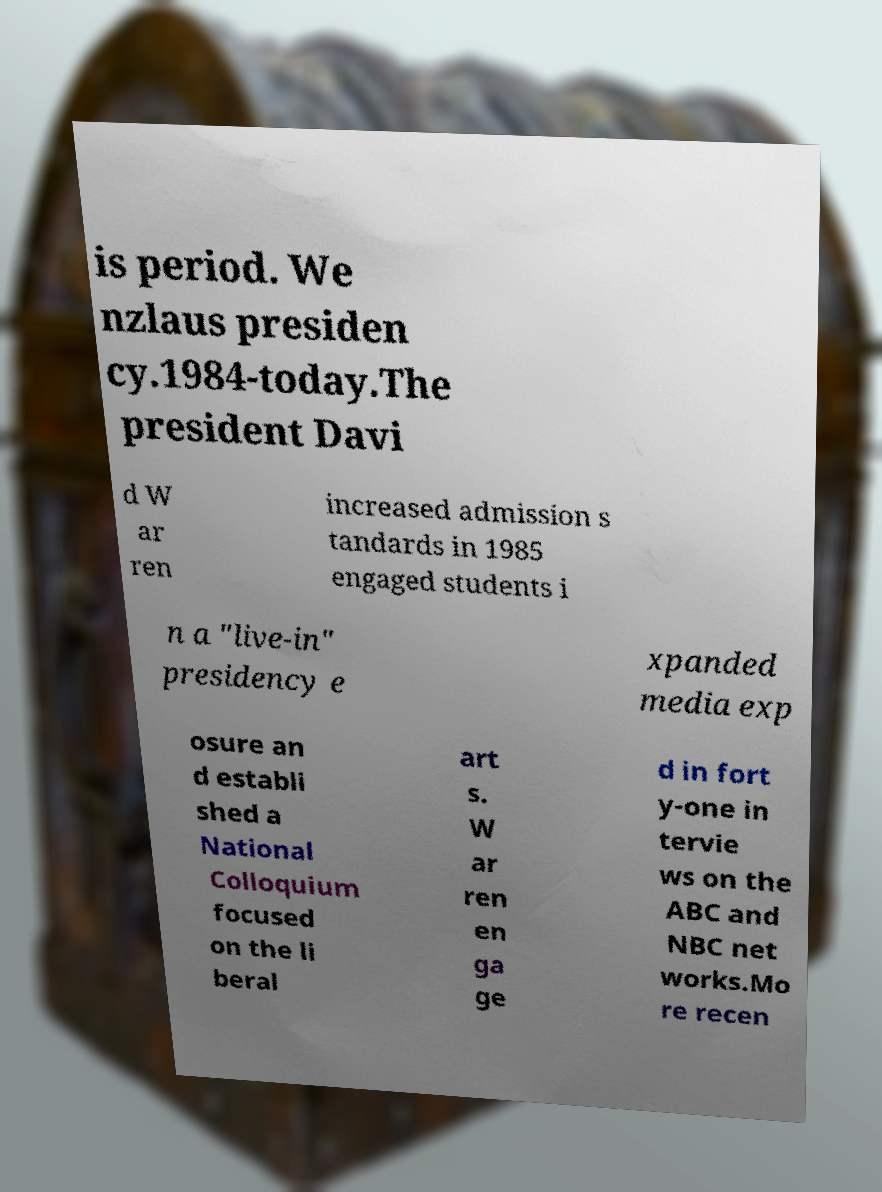What messages or text are displayed in this image? I need them in a readable, typed format. is period. We nzlaus presiden cy.1984-today.The president Davi d W ar ren increased admission s tandards in 1985 engaged students i n a "live-in" presidency e xpanded media exp osure an d establi shed a National Colloquium focused on the li beral art s. W ar ren en ga ge d in fort y-one in tervie ws on the ABC and NBC net works.Mo re recen 